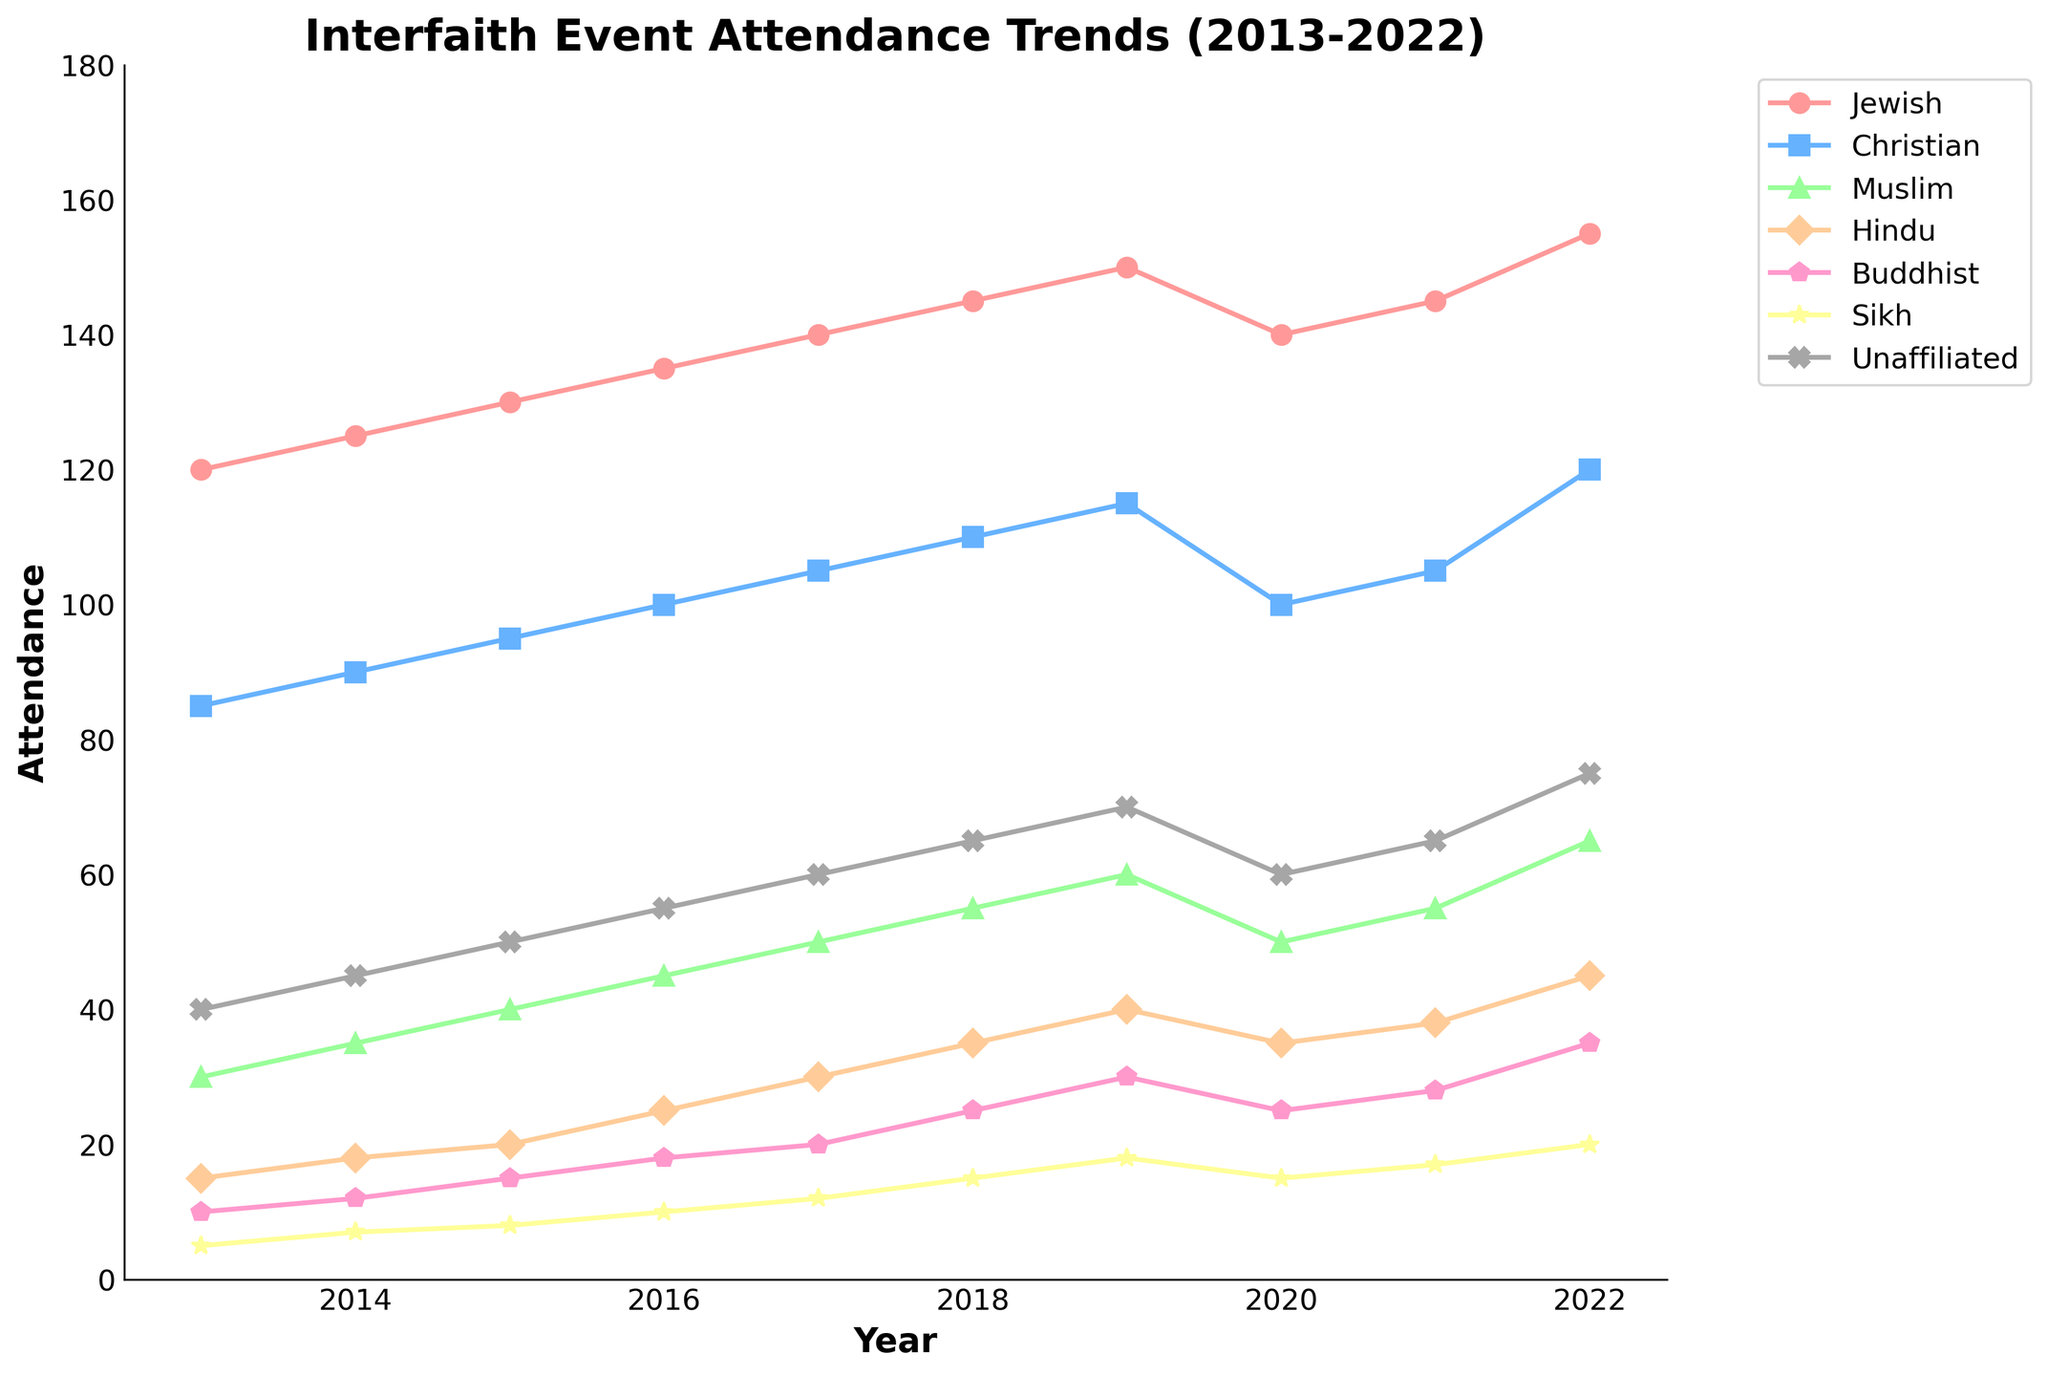Which year had the highest overall attendance across all religious groups? To find the year with the highest overall attendance, sum the attendance numbers for each year and compare. 2022: 155 + 120 + 65 + 45 + 35 + 20 + 75 = 515, while no previous year exceeds this total.
Answer: 2022 How did Jewish attendance in 2020 compare to 2021? Jewish attendance in 2020 was 140, and in 2021 it was 145. Comparing these numbers shows an increase.
Answer: Increased Which group had the smallest increase in attendance from 2013 to 2019? Calculate the increase for each group from 2013 to 2019: Jewish: 150-120=30, Christian: 115-85=30, Muslim: 60-30=30, Hindu: 40-15=25, Buddhist: 30-10=20, Sikh: 18-5=13, Unaffiliated: 70-40=30. The Sikh group had the smallest increase: 13.
Answer: Sikh Between 2019 and 2020, which group saw the largest decrease in attendance? Calculate the decrease for each group between 2019 and 2020: Jewish: 150-140=10, Christian: 115-100=15, Muslim: 60-50=10, Hindu: 40-35=5, Buddhist: 30-25=5, Sikh: 18-15=3, Unaffiliated: 70-60=10. The Christian group saw the largest decrease of 15.
Answer: Christian By how much did attendance increase for Buddhists from 2016 to 2022? Attendance for Buddhists in 2016 was 18, and in 2022 it was 35. The increase is calculated as 35 - 18 = 17.
Answer: 17 Which religious group had the highest attendance in 2018, and what was the figure? Look at the attendance values for 2018: Jewish: 145, Christian: 110, Muslim: 55, Hindu: 35, Buddhist: 25, Sikh: 15, Unaffiliated: 65. The Jewish group had the highest attendance with 145.
Answer: Jewish, 145 What was the average attendance for the Hindu group over the decade? Sum the Hindu attendances and then divide by 10 years. (15+18+20+25+30+35+40+35+38+45) = 301. The average is 301/10 = 30.1.
Answer: 30.1 Did any group maintain a steady increase every year from 2013 to 2022? Assess each group to see if their attendance increased every year without decline. The Jewish group shows consistent increase: 120, 125, 130, 135, 140, 145, 150, 140, 145, 155 - with a decline in 2020. No group had a steady increase every year.
Answer: No What color is used to represent the Buddhist group in the plot? The colors identified in the code match the plot's legend. The Buddhist group corresponds to the light pinkish color observed (Hex color in code: #FF99CC).
Answer: Light Pink In what year did the Unaffiliated group attendance first surpass 60? Examine the attendance for the Unaffiliated group year by year: In 2019 it reached 70, first surpassing 60.
Answer: 2019 